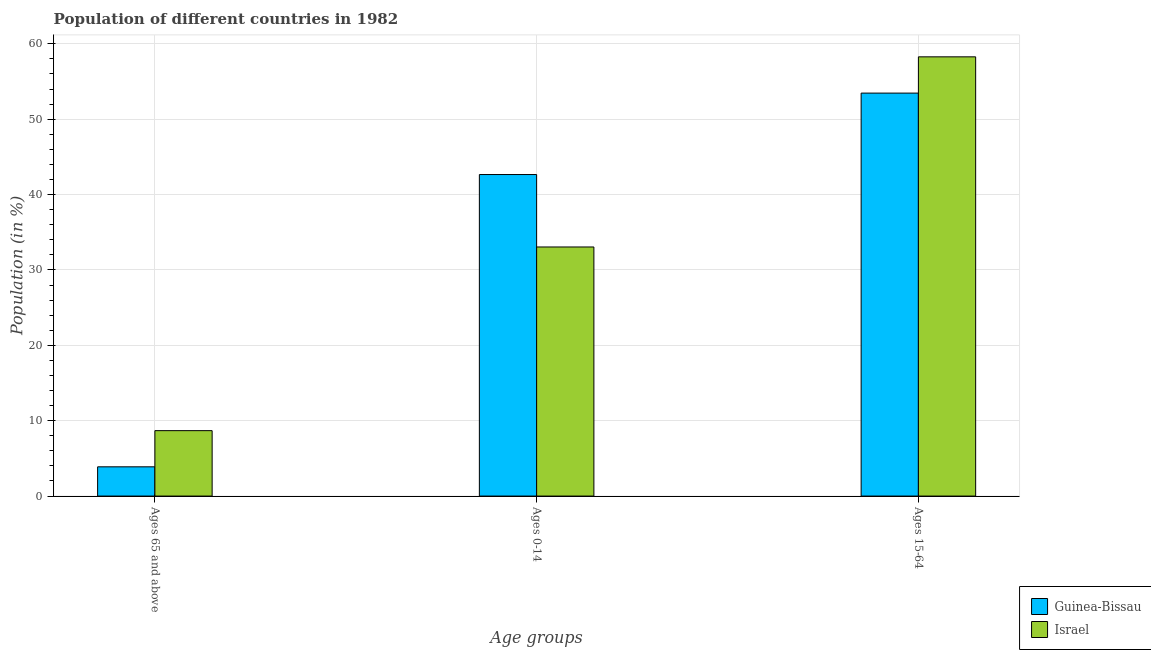How many different coloured bars are there?
Keep it short and to the point. 2. Are the number of bars per tick equal to the number of legend labels?
Make the answer very short. Yes. Are the number of bars on each tick of the X-axis equal?
Keep it short and to the point. Yes. How many bars are there on the 3rd tick from the right?
Provide a short and direct response. 2. What is the label of the 3rd group of bars from the left?
Give a very brief answer. Ages 15-64. What is the percentage of population within the age-group 0-14 in Guinea-Bissau?
Provide a succinct answer. 42.66. Across all countries, what is the maximum percentage of population within the age-group of 65 and above?
Keep it short and to the point. 8.68. Across all countries, what is the minimum percentage of population within the age-group of 65 and above?
Give a very brief answer. 3.88. In which country was the percentage of population within the age-group 15-64 maximum?
Your answer should be compact. Israel. In which country was the percentage of population within the age-group 0-14 minimum?
Offer a very short reply. Israel. What is the total percentage of population within the age-group of 65 and above in the graph?
Make the answer very short. 12.56. What is the difference between the percentage of population within the age-group of 65 and above in Guinea-Bissau and that in Israel?
Provide a short and direct response. -4.8. What is the difference between the percentage of population within the age-group 15-64 in Guinea-Bissau and the percentage of population within the age-group of 65 and above in Israel?
Your response must be concise. 44.78. What is the average percentage of population within the age-group 15-64 per country?
Provide a succinct answer. 55.87. What is the difference between the percentage of population within the age-group 15-64 and percentage of population within the age-group 0-14 in Guinea-Bissau?
Make the answer very short. 10.81. In how many countries, is the percentage of population within the age-group 0-14 greater than 8 %?
Give a very brief answer. 2. What is the ratio of the percentage of population within the age-group of 65 and above in Israel to that in Guinea-Bissau?
Ensure brevity in your answer.  2.24. Is the percentage of population within the age-group of 65 and above in Guinea-Bissau less than that in Israel?
Offer a very short reply. Yes. What is the difference between the highest and the second highest percentage of population within the age-group of 65 and above?
Your answer should be very brief. 4.8. What is the difference between the highest and the lowest percentage of population within the age-group 0-14?
Your answer should be compact. 9.61. In how many countries, is the percentage of population within the age-group of 65 and above greater than the average percentage of population within the age-group of 65 and above taken over all countries?
Provide a succinct answer. 1. What does the 1st bar from the left in Ages 0-14 represents?
Provide a short and direct response. Guinea-Bissau. What is the difference between two consecutive major ticks on the Y-axis?
Provide a succinct answer. 10. Does the graph contain grids?
Keep it short and to the point. Yes. How many legend labels are there?
Offer a very short reply. 2. What is the title of the graph?
Your response must be concise. Population of different countries in 1982. What is the label or title of the X-axis?
Your response must be concise. Age groups. What is the Population (in %) of Guinea-Bissau in Ages 65 and above?
Your answer should be very brief. 3.88. What is the Population (in %) of Israel in Ages 65 and above?
Give a very brief answer. 8.68. What is the Population (in %) of Guinea-Bissau in Ages 0-14?
Offer a terse response. 42.66. What is the Population (in %) of Israel in Ages 0-14?
Offer a very short reply. 33.05. What is the Population (in %) of Guinea-Bissau in Ages 15-64?
Your answer should be very brief. 53.46. What is the Population (in %) in Israel in Ages 15-64?
Your response must be concise. 58.27. Across all Age groups, what is the maximum Population (in %) of Guinea-Bissau?
Offer a terse response. 53.46. Across all Age groups, what is the maximum Population (in %) of Israel?
Your answer should be very brief. 58.27. Across all Age groups, what is the minimum Population (in %) in Guinea-Bissau?
Give a very brief answer. 3.88. Across all Age groups, what is the minimum Population (in %) in Israel?
Your response must be concise. 8.68. What is the total Population (in %) in Israel in the graph?
Provide a succinct answer. 100. What is the difference between the Population (in %) in Guinea-Bissau in Ages 65 and above and that in Ages 0-14?
Your answer should be very brief. -38.78. What is the difference between the Population (in %) of Israel in Ages 65 and above and that in Ages 0-14?
Your answer should be very brief. -24.37. What is the difference between the Population (in %) of Guinea-Bissau in Ages 65 and above and that in Ages 15-64?
Offer a very short reply. -49.58. What is the difference between the Population (in %) in Israel in Ages 65 and above and that in Ages 15-64?
Provide a succinct answer. -49.59. What is the difference between the Population (in %) in Guinea-Bissau in Ages 0-14 and that in Ages 15-64?
Provide a short and direct response. -10.81. What is the difference between the Population (in %) in Israel in Ages 0-14 and that in Ages 15-64?
Offer a terse response. -25.23. What is the difference between the Population (in %) in Guinea-Bissau in Ages 65 and above and the Population (in %) in Israel in Ages 0-14?
Offer a terse response. -29.17. What is the difference between the Population (in %) of Guinea-Bissau in Ages 65 and above and the Population (in %) of Israel in Ages 15-64?
Ensure brevity in your answer.  -54.39. What is the difference between the Population (in %) of Guinea-Bissau in Ages 0-14 and the Population (in %) of Israel in Ages 15-64?
Keep it short and to the point. -15.62. What is the average Population (in %) of Guinea-Bissau per Age groups?
Ensure brevity in your answer.  33.33. What is the average Population (in %) of Israel per Age groups?
Your answer should be compact. 33.33. What is the difference between the Population (in %) in Guinea-Bissau and Population (in %) in Israel in Ages 65 and above?
Offer a very short reply. -4.8. What is the difference between the Population (in %) of Guinea-Bissau and Population (in %) of Israel in Ages 0-14?
Offer a terse response. 9.61. What is the difference between the Population (in %) of Guinea-Bissau and Population (in %) of Israel in Ages 15-64?
Keep it short and to the point. -4.81. What is the ratio of the Population (in %) in Guinea-Bissau in Ages 65 and above to that in Ages 0-14?
Provide a short and direct response. 0.09. What is the ratio of the Population (in %) of Israel in Ages 65 and above to that in Ages 0-14?
Give a very brief answer. 0.26. What is the ratio of the Population (in %) of Guinea-Bissau in Ages 65 and above to that in Ages 15-64?
Make the answer very short. 0.07. What is the ratio of the Population (in %) in Israel in Ages 65 and above to that in Ages 15-64?
Offer a terse response. 0.15. What is the ratio of the Population (in %) in Guinea-Bissau in Ages 0-14 to that in Ages 15-64?
Provide a short and direct response. 0.8. What is the ratio of the Population (in %) of Israel in Ages 0-14 to that in Ages 15-64?
Your answer should be very brief. 0.57. What is the difference between the highest and the second highest Population (in %) of Guinea-Bissau?
Your response must be concise. 10.81. What is the difference between the highest and the second highest Population (in %) in Israel?
Offer a terse response. 25.23. What is the difference between the highest and the lowest Population (in %) of Guinea-Bissau?
Provide a short and direct response. 49.58. What is the difference between the highest and the lowest Population (in %) in Israel?
Make the answer very short. 49.59. 